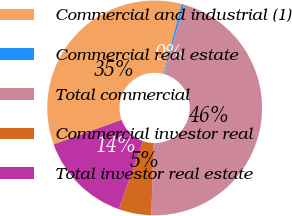<chart> <loc_0><loc_0><loc_500><loc_500><pie_chart><fcel>Commercial and industrial (1)<fcel>Commercial real estate<fcel>Total commercial<fcel>Commercial investor real<fcel>Total investor real estate<nl><fcel>34.57%<fcel>0.35%<fcel>46.09%<fcel>4.92%<fcel>14.07%<nl></chart> 